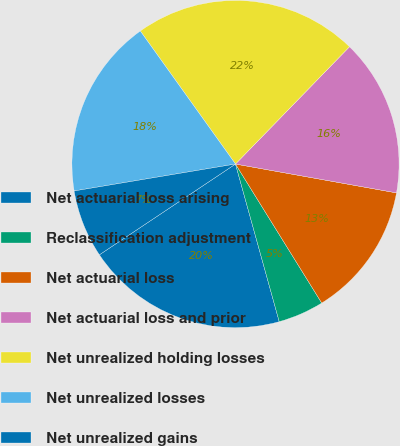Convert chart to OTSL. <chart><loc_0><loc_0><loc_500><loc_500><pie_chart><fcel>Net actuarial loss arising<fcel>Reclassification adjustment<fcel>Net actuarial loss<fcel>Net actuarial loss and prior<fcel>Net unrealized holding losses<fcel>Net unrealized losses<fcel>Net unrealized gains<nl><fcel>19.95%<fcel>4.53%<fcel>13.34%<fcel>15.55%<fcel>22.16%<fcel>17.75%<fcel>6.73%<nl></chart> 